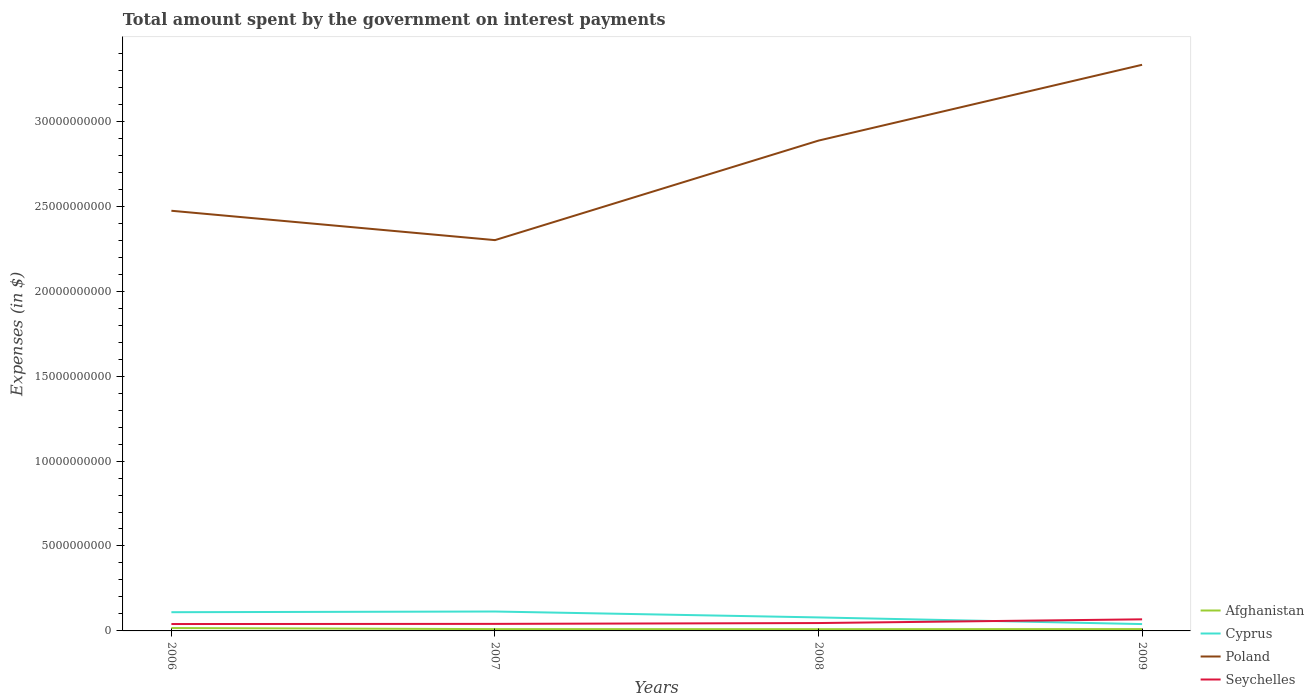How many different coloured lines are there?
Ensure brevity in your answer.  4. Across all years, what is the maximum amount spent on interest payments by the government in Afghanistan?
Your response must be concise. 1.03e+08. In which year was the amount spent on interest payments by the government in Poland maximum?
Keep it short and to the point. 2007. What is the total amount spent on interest payments by the government in Poland in the graph?
Offer a terse response. -4.46e+09. What is the difference between the highest and the second highest amount spent on interest payments by the government in Cyprus?
Your answer should be very brief. 7.39e+08. What is the difference between the highest and the lowest amount spent on interest payments by the government in Seychelles?
Your response must be concise. 1. Is the amount spent on interest payments by the government in Seychelles strictly greater than the amount spent on interest payments by the government in Afghanistan over the years?
Give a very brief answer. No. What is the difference between two consecutive major ticks on the Y-axis?
Keep it short and to the point. 5.00e+09. Are the values on the major ticks of Y-axis written in scientific E-notation?
Make the answer very short. No. Does the graph contain grids?
Offer a very short reply. No. What is the title of the graph?
Keep it short and to the point. Total amount spent by the government on interest payments. Does "Guinea-Bissau" appear as one of the legend labels in the graph?
Offer a very short reply. No. What is the label or title of the Y-axis?
Your response must be concise. Expenses (in $). What is the Expenses (in $) in Afghanistan in 2006?
Offer a very short reply. 1.69e+08. What is the Expenses (in $) in Cyprus in 2006?
Your answer should be compact. 1.10e+09. What is the Expenses (in $) of Poland in 2006?
Ensure brevity in your answer.  2.47e+1. What is the Expenses (in $) of Seychelles in 2006?
Keep it short and to the point. 4.06e+08. What is the Expenses (in $) in Afghanistan in 2007?
Make the answer very short. 1.07e+08. What is the Expenses (in $) of Cyprus in 2007?
Your answer should be compact. 1.14e+09. What is the Expenses (in $) of Poland in 2007?
Offer a terse response. 2.30e+1. What is the Expenses (in $) in Seychelles in 2007?
Provide a short and direct response. 4.15e+08. What is the Expenses (in $) of Afghanistan in 2008?
Give a very brief answer. 1.03e+08. What is the Expenses (in $) in Cyprus in 2008?
Provide a succinct answer. 7.95e+08. What is the Expenses (in $) of Poland in 2008?
Keep it short and to the point. 2.89e+1. What is the Expenses (in $) in Seychelles in 2008?
Your answer should be very brief. 4.64e+08. What is the Expenses (in $) of Afghanistan in 2009?
Offer a terse response. 1.09e+08. What is the Expenses (in $) of Cyprus in 2009?
Offer a terse response. 4.03e+08. What is the Expenses (in $) of Poland in 2009?
Your response must be concise. 3.33e+1. What is the Expenses (in $) of Seychelles in 2009?
Keep it short and to the point. 6.83e+08. Across all years, what is the maximum Expenses (in $) of Afghanistan?
Your answer should be compact. 1.69e+08. Across all years, what is the maximum Expenses (in $) in Cyprus?
Ensure brevity in your answer.  1.14e+09. Across all years, what is the maximum Expenses (in $) of Poland?
Offer a very short reply. 3.33e+1. Across all years, what is the maximum Expenses (in $) of Seychelles?
Your answer should be very brief. 6.83e+08. Across all years, what is the minimum Expenses (in $) in Afghanistan?
Make the answer very short. 1.03e+08. Across all years, what is the minimum Expenses (in $) of Cyprus?
Offer a terse response. 4.03e+08. Across all years, what is the minimum Expenses (in $) in Poland?
Offer a terse response. 2.30e+1. Across all years, what is the minimum Expenses (in $) in Seychelles?
Make the answer very short. 4.06e+08. What is the total Expenses (in $) of Afghanistan in the graph?
Give a very brief answer. 4.88e+08. What is the total Expenses (in $) in Cyprus in the graph?
Provide a short and direct response. 3.44e+09. What is the total Expenses (in $) of Poland in the graph?
Give a very brief answer. 1.10e+11. What is the total Expenses (in $) in Seychelles in the graph?
Offer a very short reply. 1.97e+09. What is the difference between the Expenses (in $) of Afghanistan in 2006 and that in 2007?
Your response must be concise. 6.26e+07. What is the difference between the Expenses (in $) in Cyprus in 2006 and that in 2007?
Provide a succinct answer. -3.98e+07. What is the difference between the Expenses (in $) of Poland in 2006 and that in 2007?
Offer a terse response. 1.73e+09. What is the difference between the Expenses (in $) in Seychelles in 2006 and that in 2007?
Offer a very short reply. -8.90e+06. What is the difference between the Expenses (in $) of Afghanistan in 2006 and that in 2008?
Offer a terse response. 6.63e+07. What is the difference between the Expenses (in $) of Cyprus in 2006 and that in 2008?
Make the answer very short. 3.07e+08. What is the difference between the Expenses (in $) of Poland in 2006 and that in 2008?
Your answer should be compact. -4.13e+09. What is the difference between the Expenses (in $) of Seychelles in 2006 and that in 2008?
Ensure brevity in your answer.  -5.80e+07. What is the difference between the Expenses (in $) of Afghanistan in 2006 and that in 2009?
Keep it short and to the point. 6.07e+07. What is the difference between the Expenses (in $) of Cyprus in 2006 and that in 2009?
Keep it short and to the point. 6.99e+08. What is the difference between the Expenses (in $) in Poland in 2006 and that in 2009?
Your answer should be very brief. -8.59e+09. What is the difference between the Expenses (in $) in Seychelles in 2006 and that in 2009?
Make the answer very short. -2.77e+08. What is the difference between the Expenses (in $) of Afghanistan in 2007 and that in 2008?
Your answer should be very brief. 3.63e+06. What is the difference between the Expenses (in $) in Cyprus in 2007 and that in 2008?
Provide a succinct answer. 3.47e+08. What is the difference between the Expenses (in $) in Poland in 2007 and that in 2008?
Provide a succinct answer. -5.86e+09. What is the difference between the Expenses (in $) in Seychelles in 2007 and that in 2008?
Make the answer very short. -4.91e+07. What is the difference between the Expenses (in $) of Afghanistan in 2007 and that in 2009?
Offer a very short reply. -1.90e+06. What is the difference between the Expenses (in $) of Cyprus in 2007 and that in 2009?
Your response must be concise. 7.39e+08. What is the difference between the Expenses (in $) in Poland in 2007 and that in 2009?
Keep it short and to the point. -1.03e+1. What is the difference between the Expenses (in $) of Seychelles in 2007 and that in 2009?
Ensure brevity in your answer.  -2.68e+08. What is the difference between the Expenses (in $) of Afghanistan in 2008 and that in 2009?
Offer a very short reply. -5.54e+06. What is the difference between the Expenses (in $) in Cyprus in 2008 and that in 2009?
Provide a succinct answer. 3.92e+08. What is the difference between the Expenses (in $) in Poland in 2008 and that in 2009?
Provide a succinct answer. -4.46e+09. What is the difference between the Expenses (in $) of Seychelles in 2008 and that in 2009?
Provide a short and direct response. -2.19e+08. What is the difference between the Expenses (in $) of Afghanistan in 2006 and the Expenses (in $) of Cyprus in 2007?
Your response must be concise. -9.73e+08. What is the difference between the Expenses (in $) of Afghanistan in 2006 and the Expenses (in $) of Poland in 2007?
Offer a terse response. -2.28e+1. What is the difference between the Expenses (in $) of Afghanistan in 2006 and the Expenses (in $) of Seychelles in 2007?
Your answer should be very brief. -2.45e+08. What is the difference between the Expenses (in $) of Cyprus in 2006 and the Expenses (in $) of Poland in 2007?
Your answer should be very brief. -2.19e+1. What is the difference between the Expenses (in $) of Cyprus in 2006 and the Expenses (in $) of Seychelles in 2007?
Your answer should be compact. 6.87e+08. What is the difference between the Expenses (in $) of Poland in 2006 and the Expenses (in $) of Seychelles in 2007?
Provide a succinct answer. 2.43e+1. What is the difference between the Expenses (in $) in Afghanistan in 2006 and the Expenses (in $) in Cyprus in 2008?
Your answer should be very brief. -6.26e+08. What is the difference between the Expenses (in $) of Afghanistan in 2006 and the Expenses (in $) of Poland in 2008?
Your answer should be compact. -2.87e+1. What is the difference between the Expenses (in $) of Afghanistan in 2006 and the Expenses (in $) of Seychelles in 2008?
Your answer should be compact. -2.95e+08. What is the difference between the Expenses (in $) in Cyprus in 2006 and the Expenses (in $) in Poland in 2008?
Offer a very short reply. -2.78e+1. What is the difference between the Expenses (in $) of Cyprus in 2006 and the Expenses (in $) of Seychelles in 2008?
Your answer should be compact. 6.38e+08. What is the difference between the Expenses (in $) of Poland in 2006 and the Expenses (in $) of Seychelles in 2008?
Offer a terse response. 2.43e+1. What is the difference between the Expenses (in $) of Afghanistan in 2006 and the Expenses (in $) of Cyprus in 2009?
Your answer should be very brief. -2.33e+08. What is the difference between the Expenses (in $) in Afghanistan in 2006 and the Expenses (in $) in Poland in 2009?
Offer a terse response. -3.32e+1. What is the difference between the Expenses (in $) of Afghanistan in 2006 and the Expenses (in $) of Seychelles in 2009?
Make the answer very short. -5.13e+08. What is the difference between the Expenses (in $) in Cyprus in 2006 and the Expenses (in $) in Poland in 2009?
Your response must be concise. -3.22e+1. What is the difference between the Expenses (in $) of Cyprus in 2006 and the Expenses (in $) of Seychelles in 2009?
Give a very brief answer. 4.19e+08. What is the difference between the Expenses (in $) of Poland in 2006 and the Expenses (in $) of Seychelles in 2009?
Keep it short and to the point. 2.41e+1. What is the difference between the Expenses (in $) of Afghanistan in 2007 and the Expenses (in $) of Cyprus in 2008?
Provide a short and direct response. -6.88e+08. What is the difference between the Expenses (in $) in Afghanistan in 2007 and the Expenses (in $) in Poland in 2008?
Your answer should be compact. -2.88e+1. What is the difference between the Expenses (in $) in Afghanistan in 2007 and the Expenses (in $) in Seychelles in 2008?
Your response must be concise. -3.57e+08. What is the difference between the Expenses (in $) of Cyprus in 2007 and the Expenses (in $) of Poland in 2008?
Your answer should be very brief. -2.77e+1. What is the difference between the Expenses (in $) of Cyprus in 2007 and the Expenses (in $) of Seychelles in 2008?
Offer a very short reply. 6.78e+08. What is the difference between the Expenses (in $) in Poland in 2007 and the Expenses (in $) in Seychelles in 2008?
Your answer should be very brief. 2.25e+1. What is the difference between the Expenses (in $) in Afghanistan in 2007 and the Expenses (in $) in Cyprus in 2009?
Provide a short and direct response. -2.96e+08. What is the difference between the Expenses (in $) of Afghanistan in 2007 and the Expenses (in $) of Poland in 2009?
Give a very brief answer. -3.32e+1. What is the difference between the Expenses (in $) of Afghanistan in 2007 and the Expenses (in $) of Seychelles in 2009?
Your answer should be very brief. -5.76e+08. What is the difference between the Expenses (in $) of Cyprus in 2007 and the Expenses (in $) of Poland in 2009?
Give a very brief answer. -3.22e+1. What is the difference between the Expenses (in $) of Cyprus in 2007 and the Expenses (in $) of Seychelles in 2009?
Make the answer very short. 4.59e+08. What is the difference between the Expenses (in $) in Poland in 2007 and the Expenses (in $) in Seychelles in 2009?
Your answer should be very brief. 2.23e+1. What is the difference between the Expenses (in $) of Afghanistan in 2008 and the Expenses (in $) of Cyprus in 2009?
Your answer should be compact. -3.00e+08. What is the difference between the Expenses (in $) of Afghanistan in 2008 and the Expenses (in $) of Poland in 2009?
Make the answer very short. -3.32e+1. What is the difference between the Expenses (in $) of Afghanistan in 2008 and the Expenses (in $) of Seychelles in 2009?
Keep it short and to the point. -5.80e+08. What is the difference between the Expenses (in $) of Cyprus in 2008 and the Expenses (in $) of Poland in 2009?
Provide a succinct answer. -3.25e+1. What is the difference between the Expenses (in $) in Cyprus in 2008 and the Expenses (in $) in Seychelles in 2009?
Provide a succinct answer. 1.12e+08. What is the difference between the Expenses (in $) in Poland in 2008 and the Expenses (in $) in Seychelles in 2009?
Keep it short and to the point. 2.82e+1. What is the average Expenses (in $) in Afghanistan per year?
Give a very brief answer. 1.22e+08. What is the average Expenses (in $) in Cyprus per year?
Give a very brief answer. 8.60e+08. What is the average Expenses (in $) of Poland per year?
Make the answer very short. 2.75e+1. What is the average Expenses (in $) of Seychelles per year?
Give a very brief answer. 4.92e+08. In the year 2006, what is the difference between the Expenses (in $) of Afghanistan and Expenses (in $) of Cyprus?
Offer a terse response. -9.33e+08. In the year 2006, what is the difference between the Expenses (in $) of Afghanistan and Expenses (in $) of Poland?
Keep it short and to the point. -2.46e+1. In the year 2006, what is the difference between the Expenses (in $) in Afghanistan and Expenses (in $) in Seychelles?
Your answer should be very brief. -2.37e+08. In the year 2006, what is the difference between the Expenses (in $) of Cyprus and Expenses (in $) of Poland?
Ensure brevity in your answer.  -2.36e+1. In the year 2006, what is the difference between the Expenses (in $) in Cyprus and Expenses (in $) in Seychelles?
Your response must be concise. 6.96e+08. In the year 2006, what is the difference between the Expenses (in $) of Poland and Expenses (in $) of Seychelles?
Give a very brief answer. 2.43e+1. In the year 2007, what is the difference between the Expenses (in $) in Afghanistan and Expenses (in $) in Cyprus?
Provide a short and direct response. -1.04e+09. In the year 2007, what is the difference between the Expenses (in $) of Afghanistan and Expenses (in $) of Poland?
Make the answer very short. -2.29e+1. In the year 2007, what is the difference between the Expenses (in $) of Afghanistan and Expenses (in $) of Seychelles?
Ensure brevity in your answer.  -3.08e+08. In the year 2007, what is the difference between the Expenses (in $) in Cyprus and Expenses (in $) in Poland?
Ensure brevity in your answer.  -2.19e+1. In the year 2007, what is the difference between the Expenses (in $) of Cyprus and Expenses (in $) of Seychelles?
Your answer should be compact. 7.27e+08. In the year 2007, what is the difference between the Expenses (in $) of Poland and Expenses (in $) of Seychelles?
Offer a very short reply. 2.26e+1. In the year 2008, what is the difference between the Expenses (in $) of Afghanistan and Expenses (in $) of Cyprus?
Offer a terse response. -6.92e+08. In the year 2008, what is the difference between the Expenses (in $) in Afghanistan and Expenses (in $) in Poland?
Your answer should be compact. -2.88e+1. In the year 2008, what is the difference between the Expenses (in $) in Afghanistan and Expenses (in $) in Seychelles?
Your response must be concise. -3.61e+08. In the year 2008, what is the difference between the Expenses (in $) in Cyprus and Expenses (in $) in Poland?
Provide a succinct answer. -2.81e+1. In the year 2008, what is the difference between the Expenses (in $) in Cyprus and Expenses (in $) in Seychelles?
Provide a succinct answer. 3.31e+08. In the year 2008, what is the difference between the Expenses (in $) of Poland and Expenses (in $) of Seychelles?
Ensure brevity in your answer.  2.84e+1. In the year 2009, what is the difference between the Expenses (in $) of Afghanistan and Expenses (in $) of Cyprus?
Your answer should be very brief. -2.94e+08. In the year 2009, what is the difference between the Expenses (in $) of Afghanistan and Expenses (in $) of Poland?
Your response must be concise. -3.32e+1. In the year 2009, what is the difference between the Expenses (in $) of Afghanistan and Expenses (in $) of Seychelles?
Your answer should be compact. -5.74e+08. In the year 2009, what is the difference between the Expenses (in $) of Cyprus and Expenses (in $) of Poland?
Your answer should be very brief. -3.29e+1. In the year 2009, what is the difference between the Expenses (in $) in Cyprus and Expenses (in $) in Seychelles?
Your response must be concise. -2.80e+08. In the year 2009, what is the difference between the Expenses (in $) of Poland and Expenses (in $) of Seychelles?
Ensure brevity in your answer.  3.26e+1. What is the ratio of the Expenses (in $) in Afghanistan in 2006 to that in 2007?
Offer a terse response. 1.59. What is the ratio of the Expenses (in $) of Cyprus in 2006 to that in 2007?
Provide a succinct answer. 0.97. What is the ratio of the Expenses (in $) in Poland in 2006 to that in 2007?
Offer a very short reply. 1.08. What is the ratio of the Expenses (in $) in Seychelles in 2006 to that in 2007?
Give a very brief answer. 0.98. What is the ratio of the Expenses (in $) of Afghanistan in 2006 to that in 2008?
Offer a terse response. 1.64. What is the ratio of the Expenses (in $) of Cyprus in 2006 to that in 2008?
Keep it short and to the point. 1.39. What is the ratio of the Expenses (in $) in Poland in 2006 to that in 2008?
Provide a succinct answer. 0.86. What is the ratio of the Expenses (in $) in Seychelles in 2006 to that in 2008?
Your answer should be very brief. 0.87. What is the ratio of the Expenses (in $) of Afghanistan in 2006 to that in 2009?
Your answer should be very brief. 1.56. What is the ratio of the Expenses (in $) in Cyprus in 2006 to that in 2009?
Keep it short and to the point. 2.74. What is the ratio of the Expenses (in $) in Poland in 2006 to that in 2009?
Offer a terse response. 0.74. What is the ratio of the Expenses (in $) in Seychelles in 2006 to that in 2009?
Give a very brief answer. 0.59. What is the ratio of the Expenses (in $) in Afghanistan in 2007 to that in 2008?
Your answer should be compact. 1.04. What is the ratio of the Expenses (in $) in Cyprus in 2007 to that in 2008?
Give a very brief answer. 1.44. What is the ratio of the Expenses (in $) in Poland in 2007 to that in 2008?
Provide a succinct answer. 0.8. What is the ratio of the Expenses (in $) in Seychelles in 2007 to that in 2008?
Your answer should be very brief. 0.89. What is the ratio of the Expenses (in $) of Afghanistan in 2007 to that in 2009?
Make the answer very short. 0.98. What is the ratio of the Expenses (in $) of Cyprus in 2007 to that in 2009?
Offer a very short reply. 2.84. What is the ratio of the Expenses (in $) of Poland in 2007 to that in 2009?
Your answer should be compact. 0.69. What is the ratio of the Expenses (in $) of Seychelles in 2007 to that in 2009?
Ensure brevity in your answer.  0.61. What is the ratio of the Expenses (in $) of Afghanistan in 2008 to that in 2009?
Provide a short and direct response. 0.95. What is the ratio of the Expenses (in $) in Cyprus in 2008 to that in 2009?
Provide a short and direct response. 1.97. What is the ratio of the Expenses (in $) of Poland in 2008 to that in 2009?
Make the answer very short. 0.87. What is the ratio of the Expenses (in $) of Seychelles in 2008 to that in 2009?
Keep it short and to the point. 0.68. What is the difference between the highest and the second highest Expenses (in $) in Afghanistan?
Offer a terse response. 6.07e+07. What is the difference between the highest and the second highest Expenses (in $) of Cyprus?
Provide a short and direct response. 3.98e+07. What is the difference between the highest and the second highest Expenses (in $) of Poland?
Your answer should be very brief. 4.46e+09. What is the difference between the highest and the second highest Expenses (in $) in Seychelles?
Your answer should be compact. 2.19e+08. What is the difference between the highest and the lowest Expenses (in $) in Afghanistan?
Make the answer very short. 6.63e+07. What is the difference between the highest and the lowest Expenses (in $) of Cyprus?
Ensure brevity in your answer.  7.39e+08. What is the difference between the highest and the lowest Expenses (in $) of Poland?
Give a very brief answer. 1.03e+1. What is the difference between the highest and the lowest Expenses (in $) of Seychelles?
Your answer should be compact. 2.77e+08. 